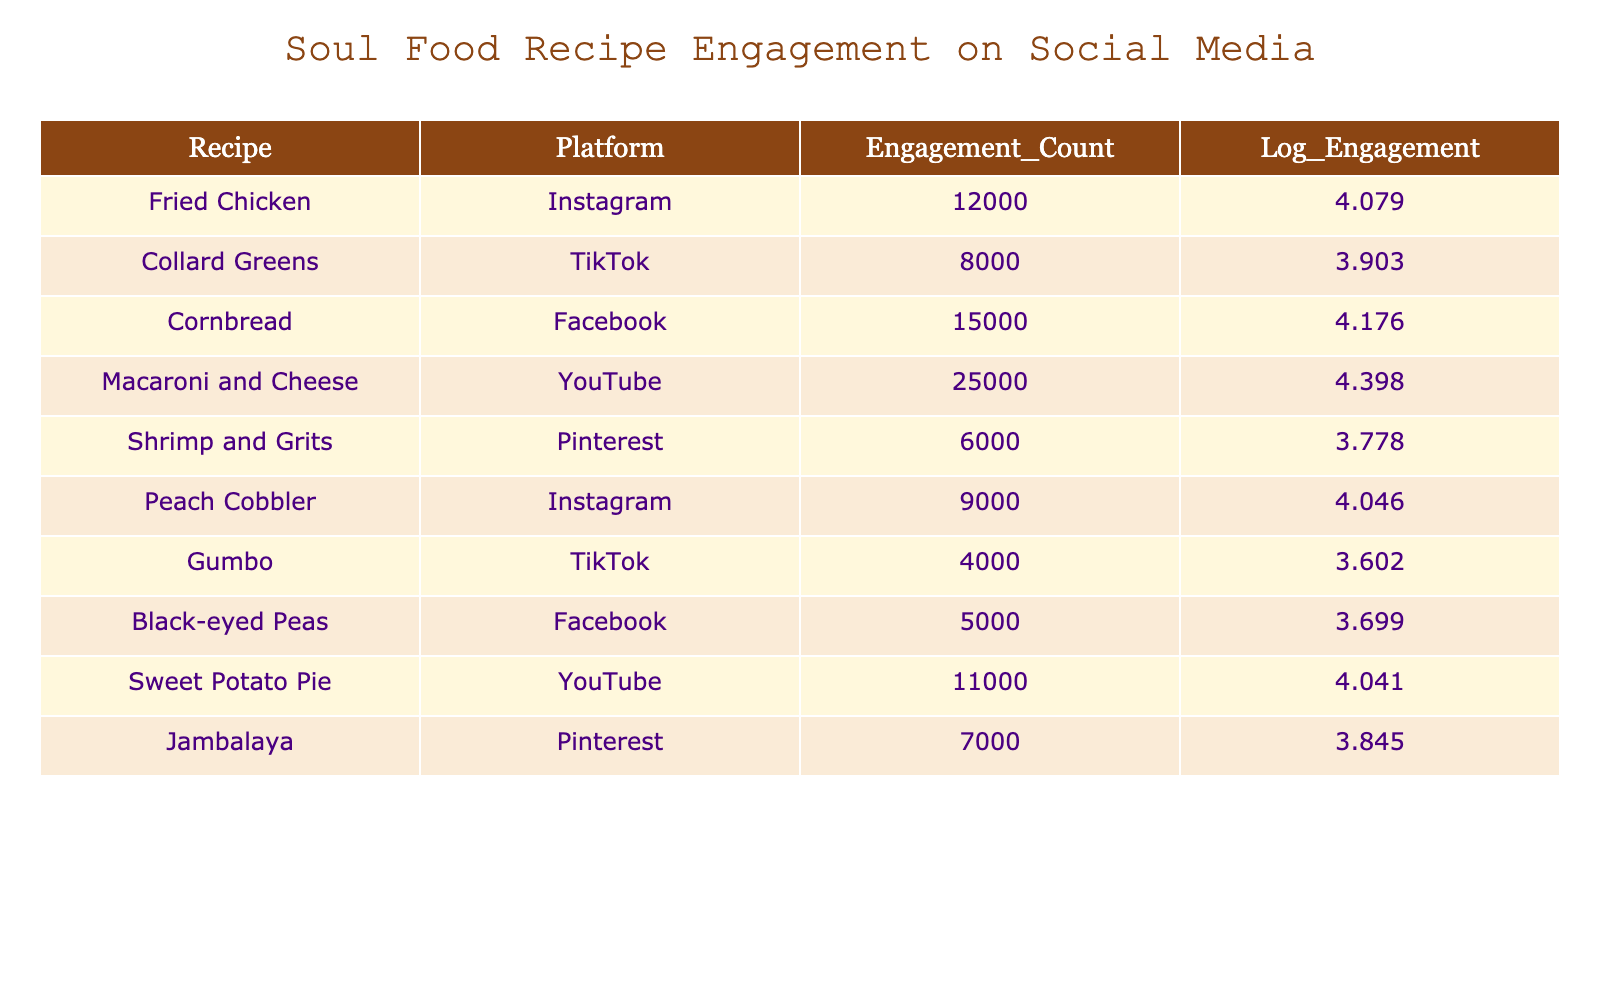What is the engagement count for Peach Cobbler on Instagram? The table lists Peach Cobbler under Instagram with an engagement count of 9000.
Answer: 9000 Which recipe has the highest engagement count on YouTube? According to the table, Macaroni and Cheese has the highest engagement count on YouTube with 25000.
Answer: 25000 What is the average engagement count of the recipes on TikTok? The engagement counts for the recipes on TikTok are 8000 for Collard Greens and 4000 for Gumbo. The average is (8000 + 4000) / 2 = 6000.
Answer: 6000 Is Shrimp and Grits more popular on Pinterest than Gumbo on TikTok? Shrimp and Grits has an engagement count of 6000 on Pinterest, while Gumbo has 4000 on TikTok. Since 6000 is greater than 4000, the answer is yes.
Answer: Yes Which soul food recipe had the lowest engagement count on Facebook? The table indicates that Black-eyed Peas had the lowest engagement count on Facebook, with a count of 5000.
Answer: 5000 What is the total engagement count for recipes on Instagram? From the table, the engagement counts for Instagram are 12000 (Fried Chicken) and 9000 (Peach Cobbler). Summing these gives 12000 + 9000 = 21000.
Answer: 21000 Is the engagement count for Sweet Potato Pie higher than that for Collard Greens? Sweet Potato Pie has an engagement count of 11000, while Collard Greens has 8000. Since 11000 is greater than 8000, yes, it is higher.
Answer: Yes How does the engagement count of Cornbread compare to that of Black-eyed Peas? Cornbread has an engagement count of 15000, while Black-eyed Peas has 5000. Since 15000 is significantly higher than 5000, Cornbread is more popular.
Answer: Cornbread is more popular What is the difference in engagement count between Macaroni and Cheese and Sweet Potato Pie? Macaroni and Cheese has an engagement count of 25000, and Sweet Potato Pie has 11000. The difference is 25000 - 11000 = 14000.
Answer: 14000 